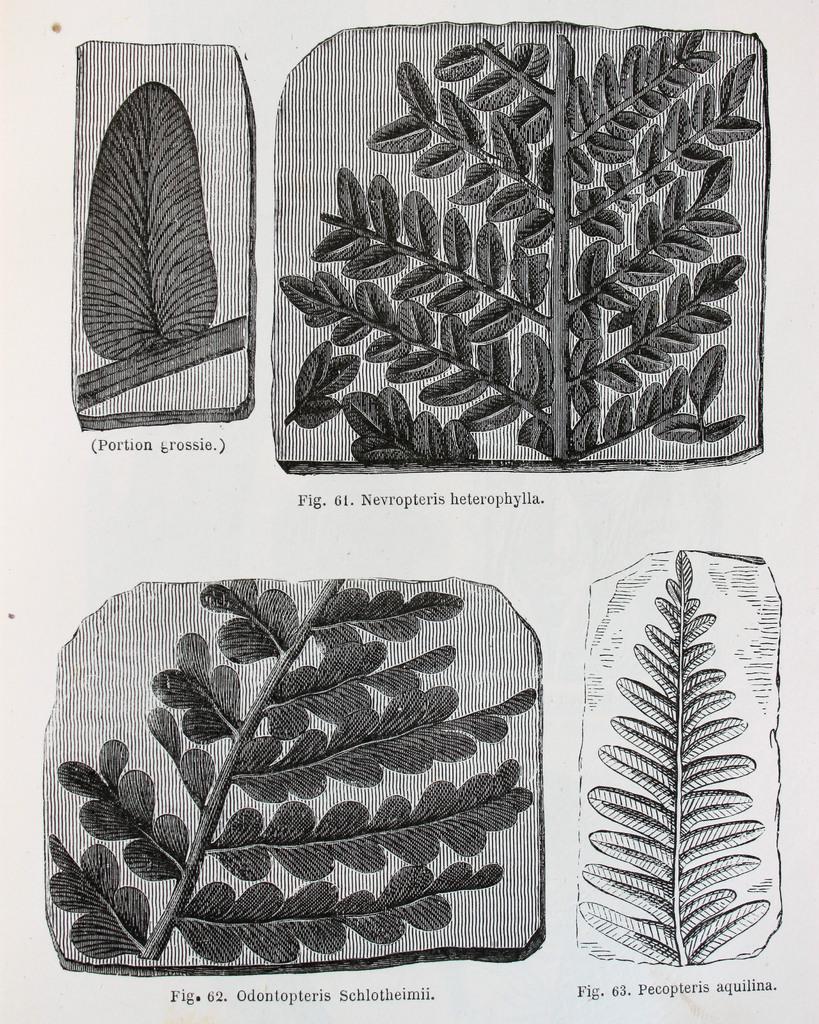In one or two sentences, can you explain what this image depicts? This is the painting image of leaves. 